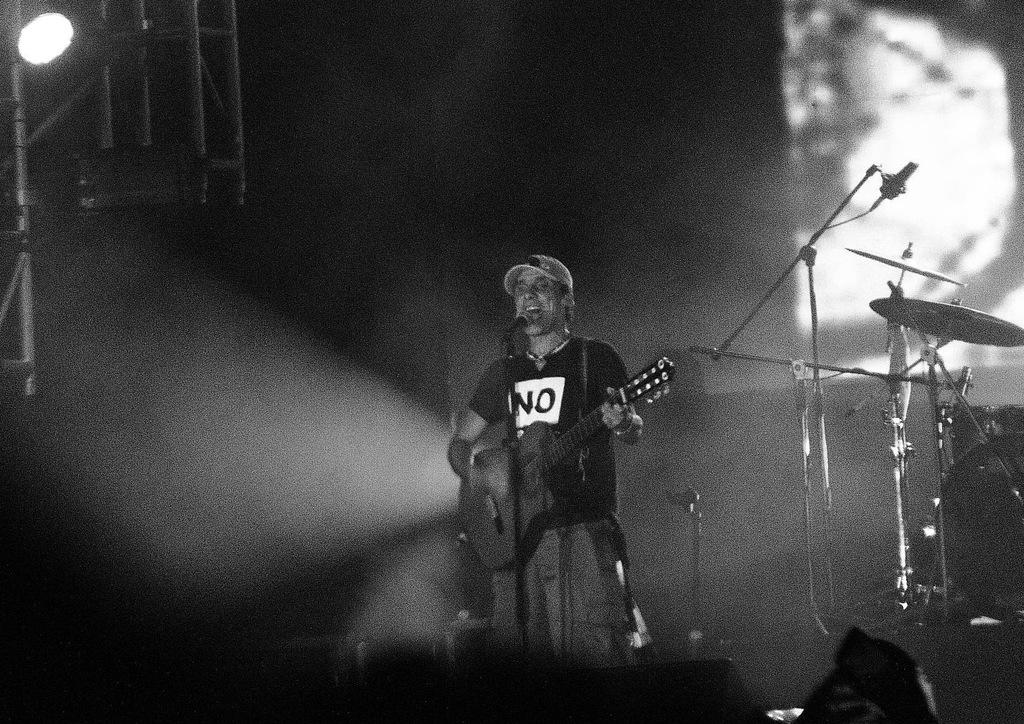What is the person in the image doing? The person is standing and holding a guitar. What object is in front of the person? There is a microphone in front of the person. What can be seen in the background of the image? There are musical instruments and a light visible in the background. What type of bells can be heard ringing in the image? There are no bells present in the image, and therefore no sound can be heard. 